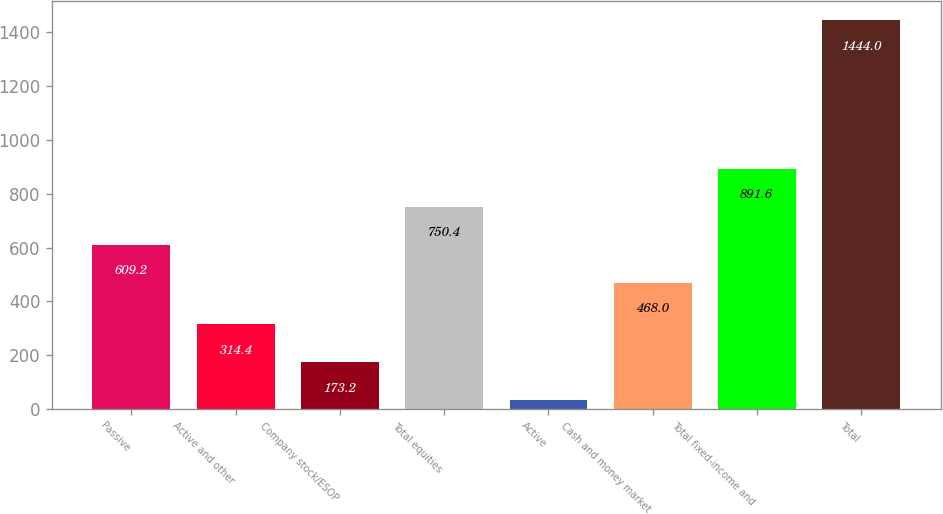Convert chart to OTSL. <chart><loc_0><loc_0><loc_500><loc_500><bar_chart><fcel>Passive<fcel>Active and other<fcel>Company stock/ESOP<fcel>Total equities<fcel>Active<fcel>Cash and money market<fcel>Total fixed-income and<fcel>Total<nl><fcel>609.2<fcel>314.4<fcel>173.2<fcel>750.4<fcel>32<fcel>468<fcel>891.6<fcel>1444<nl></chart> 